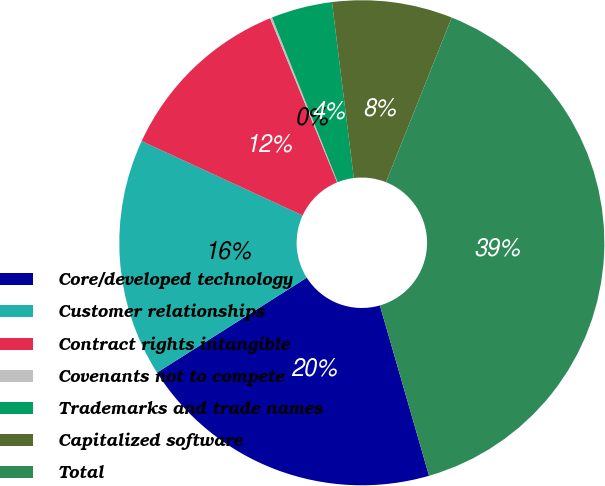<chart> <loc_0><loc_0><loc_500><loc_500><pie_chart><fcel>Core/developed technology<fcel>Customer relationships<fcel>Contract rights intangible<fcel>Covenants not to compete<fcel>Trademarks and trade names<fcel>Capitalized software<fcel>Total<nl><fcel>20.48%<fcel>15.88%<fcel>11.94%<fcel>0.14%<fcel>4.07%<fcel>8.01%<fcel>39.49%<nl></chart> 